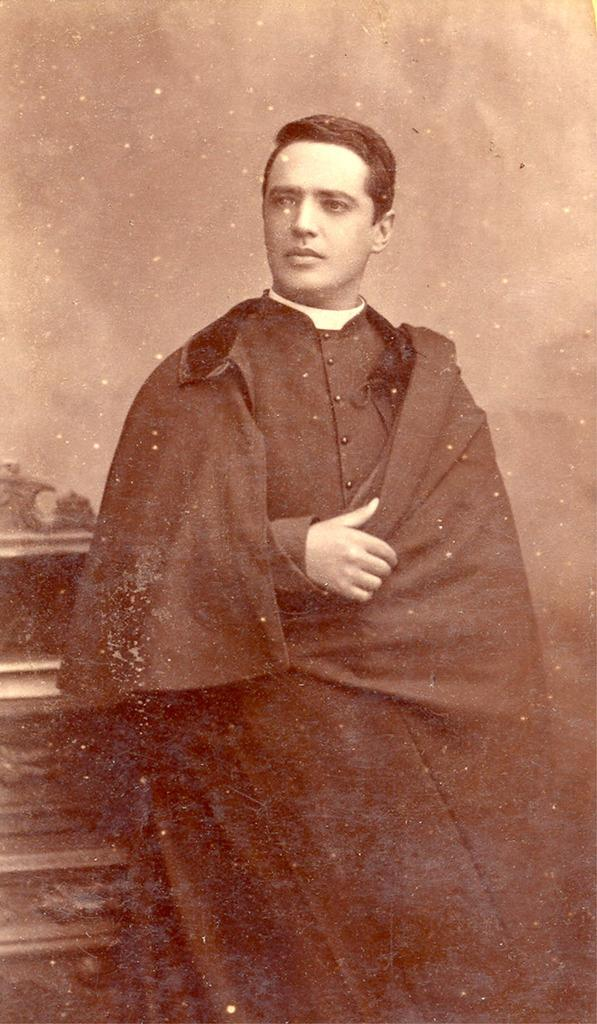What is the main subject of the image? There is a person standing in the image. Where is the person located in the image? The person is in the center of the image. What type of legal advice is the person providing in the image? There is no indication in the image that the person is a lawyer or providing legal advice. 